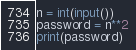<code> <loc_0><loc_0><loc_500><loc_500><_Python_>n = int(input())
password = n**2
print(password)</code> 